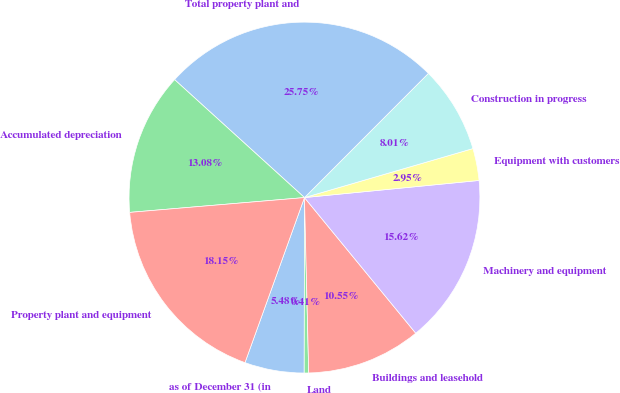Convert chart to OTSL. <chart><loc_0><loc_0><loc_500><loc_500><pie_chart><fcel>as of December 31 (in<fcel>Land<fcel>Buildings and leasehold<fcel>Machinery and equipment<fcel>Equipment with customers<fcel>Construction in progress<fcel>Total property plant and<fcel>Accumulated depreciation<fcel>Property plant and equipment<nl><fcel>5.48%<fcel>0.41%<fcel>10.55%<fcel>15.62%<fcel>2.95%<fcel>8.01%<fcel>25.75%<fcel>13.08%<fcel>18.15%<nl></chart> 